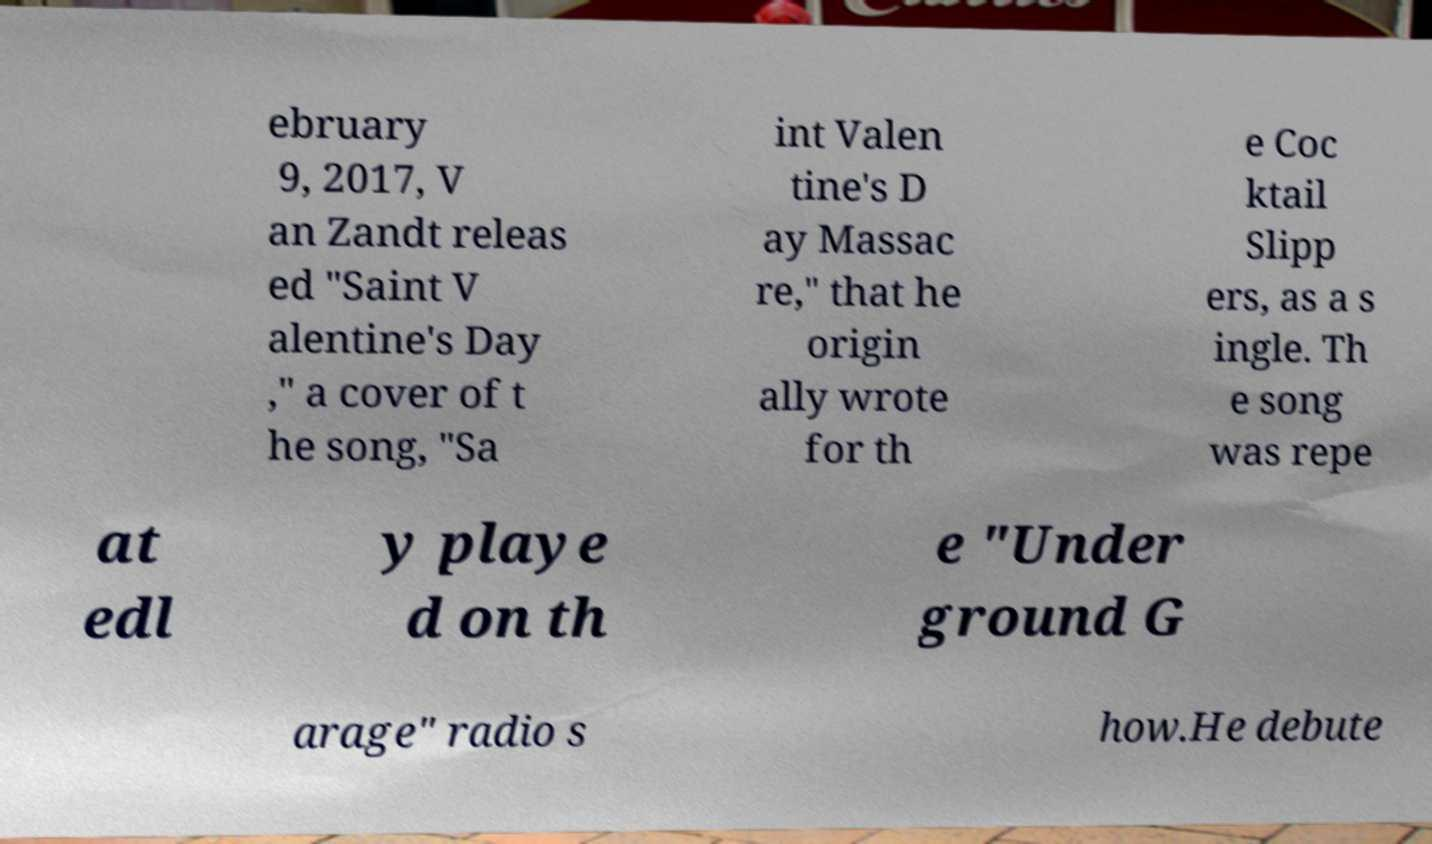Please read and relay the text visible in this image. What does it say? ebruary 9, 2017, V an Zandt releas ed "Saint V alentine's Day ," a cover of t he song, "Sa int Valen tine's D ay Massac re," that he origin ally wrote for th e Coc ktail Slipp ers, as a s ingle. Th e song was repe at edl y playe d on th e "Under ground G arage" radio s how.He debute 